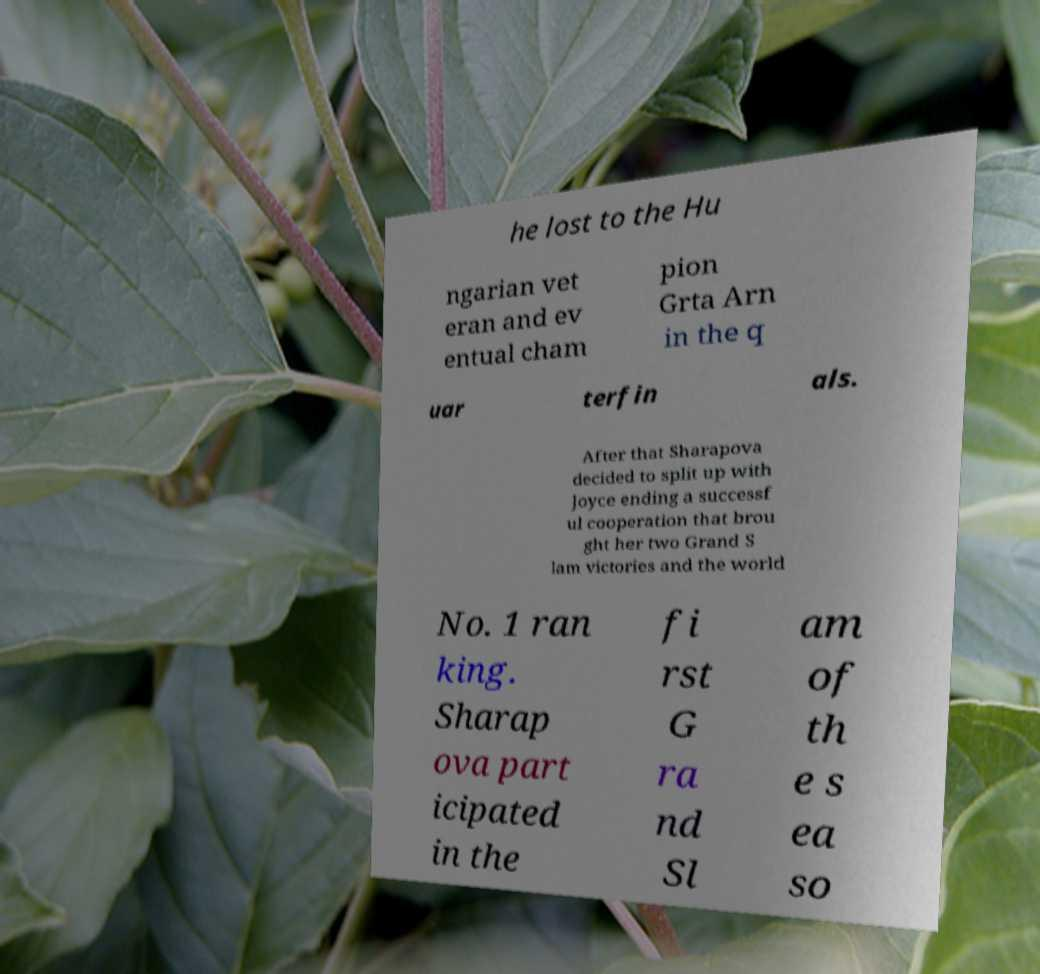Can you read and provide the text displayed in the image?This photo seems to have some interesting text. Can you extract and type it out for me? he lost to the Hu ngarian vet eran and ev entual cham pion Grta Arn in the q uar terfin als. After that Sharapova decided to split up with Joyce ending a successf ul cooperation that brou ght her two Grand S lam victories and the world No. 1 ran king. Sharap ova part icipated in the fi rst G ra nd Sl am of th e s ea so 